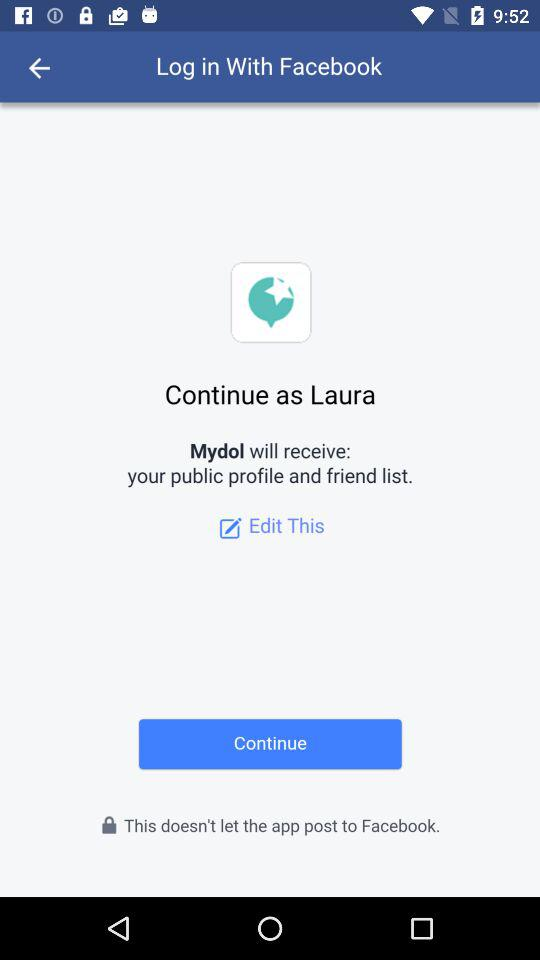What is the name of the user? The name of the user is Laura. 